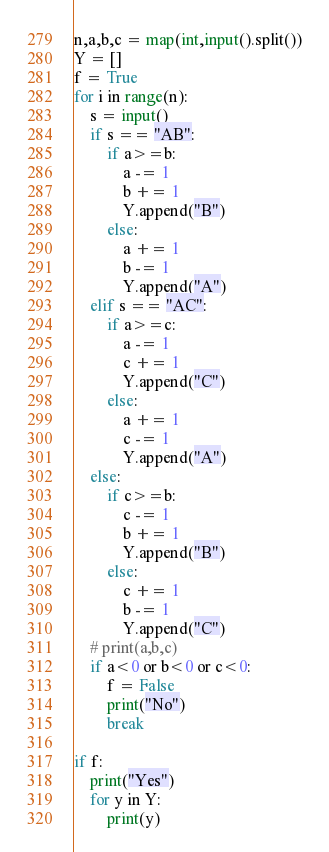Convert code to text. <code><loc_0><loc_0><loc_500><loc_500><_Python_>n,a,b,c = map(int,input().split())
Y = []
f = True
for i in range(n):
    s = input()
    if s == "AB":
        if a>=b:
            a -= 1
            b += 1
            Y.append("B")
        else:
            a += 1
            b -= 1
            Y.append("A")
    elif s == "AC":
        if a>=c:
            a -= 1
            c += 1
            Y.append("C")
        else:
            a += 1
            c -= 1
            Y.append("A")
    else:
        if c>=b:
            c -= 1
            b += 1
            Y.append("B")
        else:
            c += 1
            b -= 1
            Y.append("C")
    # print(a,b,c)
    if a<0 or b<0 or c<0:
        f = False
        print("No")
        break
        
if f:
    print("Yes")
    for y in Y:
        print(y)
</code> 